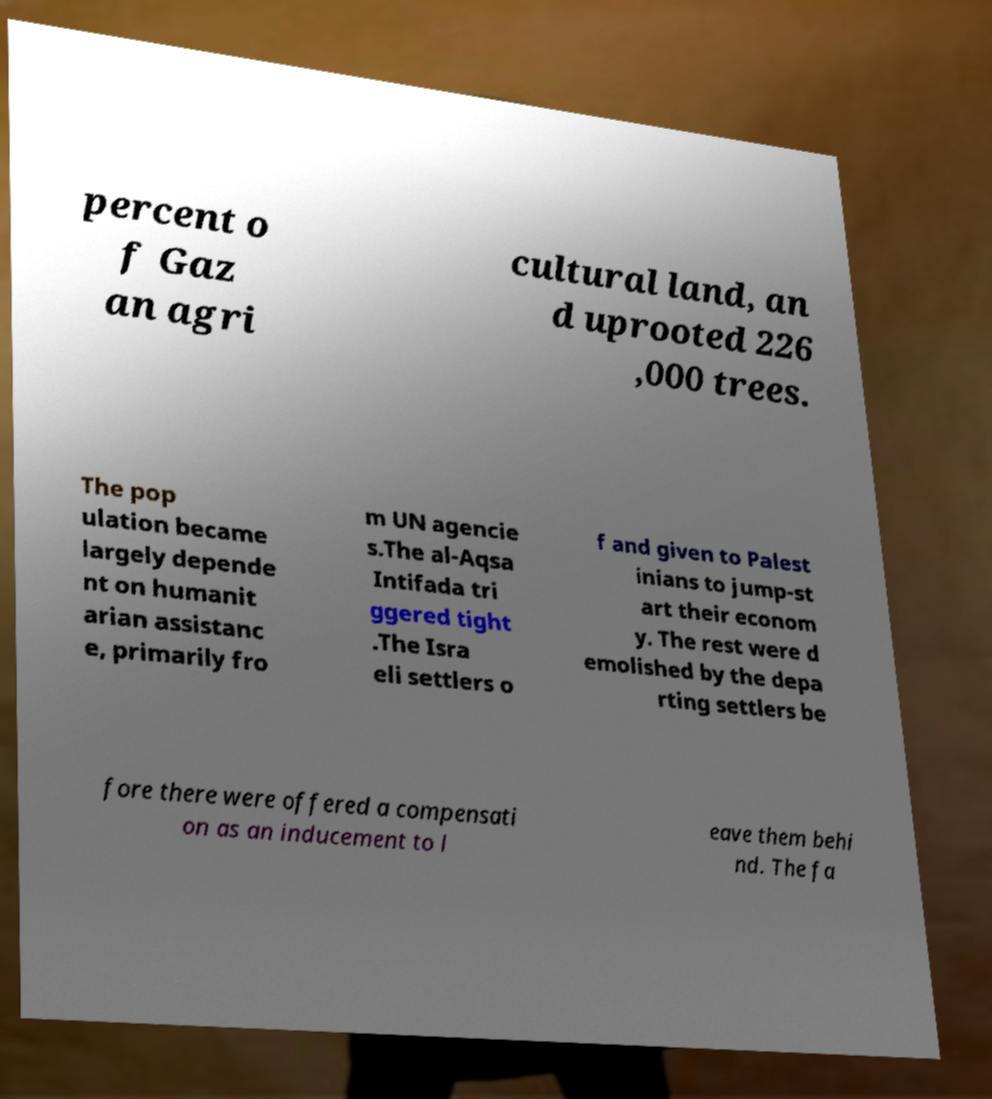Could you extract and type out the text from this image? percent o f Gaz an agri cultural land, an d uprooted 226 ,000 trees. The pop ulation became largely depende nt on humanit arian assistanc e, primarily fro m UN agencie s.The al-Aqsa Intifada tri ggered tight .The Isra eli settlers o f and given to Palest inians to jump-st art their econom y. The rest were d emolished by the depa rting settlers be fore there were offered a compensati on as an inducement to l eave them behi nd. The fa 